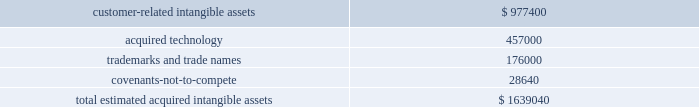Reach in the united states , adding a 1400-person direct sales force , over 300000 merchants and $ 130 billion in annual payments volume .
Goodwill of $ 3.2 billion arising from the merger , included in the north america segment , was attributable to expected growth opportunities , potential synergies from combining our existing businesses and an assembled workforce , and is not deductible for income tax purposes .
Due to the timing of our merger with heartland , we are still in the process of assigning goodwill to our reporting units .
During the year ended may 31 , 2016 , we incurred transaction costs in connection with the merger of $ 24.4 million , which are recorded in selling , general and administrative expenses in the consolidated statements of income .
The following reflects the preliminary estimated fair values of the identified intangible assets ( in thousands ) : .
The preliminary estimated fair value of customer-related intangible assets was determined using the income approach , which is based on projected cash flows discounted to their present value using discount rates that consider the timing and risk of the forecasted cash flows .
The discount rate used is the average estimated value of a market participant 2019s cost of capital and debt , derived using customary market metrics .
Other significant assumptions include terminal value margin rates , future capital expenditures and future working capital requirements .
Acquired technology was valued using the replacement cost method , which required us to estimate the cost to construct an asset of equivalent utility at prices available at the time of the valuation analysis , with adjustments in value for physical deterioration and functional and economic obsolescence .
Trademarks and trade names were valued using the relief-from-royalty approach .
This method assumes that trade marks and trade names have value to the extent that their owner is relieved of the obligation to pay royalties for the benefits received from them .
This method required us to estimate the future revenue for the related brands , the appropriate royalty rate and the weighted-average cost of capital .
The discount rate used is the average estimated value of a market participant 2019s cost of capital and debt , derived using customary market metrics .
The weighted-average estimated amortization period for the total estimated acquired intangible assets is approximately 11 years .
The customer-related intangible assets have an estimated amortization period range of 7-20 years .
The acquired technology has an estimated amortization period of 5 years .
The trademarks and trade names have an estimated amortization period of 7 years .
Covenants-not-to-compete have an estimated amortization period range of 1-4 years .
Heartland 2019s revenues and operating income represented approximately 4% ( 4 % ) and less than 0.5% ( 0.5 % ) of our total consolidated revenues and operating income , respectively , for the year ended may 31 , 2016 .
The following unaudited pro forma information shows the results of our operations for the years ended may 31 , 2016 and may 31 , 2015 as if our merger with heartland had occurred on june 1 , 2014 .
The unaudited pro forma information reflects the effects of applying our accounting policies and certain pro forma adjustments to the combined historical financial information of global payments and heartland .
The pro forma adjustments include incremental amortization and depreciation expense , incremental interest expense associated with new long-term debt , a reduction of revenues and operating expenses associated with fair value adjustments made in applying the acquisition-method of accounting and the elimination of nonrecurring transaction costs directly related to the merger .
Global payments inc .
| 2016 form 10-k annual report 2013 67 .
What is the yearly amortization expense related acquired technology? 
Computations: (457000 / 5)
Answer: 91400.0. Reach in the united states , adding a 1400-person direct sales force , over 300000 merchants and $ 130 billion in annual payments volume .
Goodwill of $ 3.2 billion arising from the merger , included in the north america segment , was attributable to expected growth opportunities , potential synergies from combining our existing businesses and an assembled workforce , and is not deductible for income tax purposes .
Due to the timing of our merger with heartland , we are still in the process of assigning goodwill to our reporting units .
During the year ended may 31 , 2016 , we incurred transaction costs in connection with the merger of $ 24.4 million , which are recorded in selling , general and administrative expenses in the consolidated statements of income .
The following reflects the preliminary estimated fair values of the identified intangible assets ( in thousands ) : .
The preliminary estimated fair value of customer-related intangible assets was determined using the income approach , which is based on projected cash flows discounted to their present value using discount rates that consider the timing and risk of the forecasted cash flows .
The discount rate used is the average estimated value of a market participant 2019s cost of capital and debt , derived using customary market metrics .
Other significant assumptions include terminal value margin rates , future capital expenditures and future working capital requirements .
Acquired technology was valued using the replacement cost method , which required us to estimate the cost to construct an asset of equivalent utility at prices available at the time of the valuation analysis , with adjustments in value for physical deterioration and functional and economic obsolescence .
Trademarks and trade names were valued using the relief-from-royalty approach .
This method assumes that trade marks and trade names have value to the extent that their owner is relieved of the obligation to pay royalties for the benefits received from them .
This method required us to estimate the future revenue for the related brands , the appropriate royalty rate and the weighted-average cost of capital .
The discount rate used is the average estimated value of a market participant 2019s cost of capital and debt , derived using customary market metrics .
The weighted-average estimated amortization period for the total estimated acquired intangible assets is approximately 11 years .
The customer-related intangible assets have an estimated amortization period range of 7-20 years .
The acquired technology has an estimated amortization period of 5 years .
The trademarks and trade names have an estimated amortization period of 7 years .
Covenants-not-to-compete have an estimated amortization period range of 1-4 years .
Heartland 2019s revenues and operating income represented approximately 4% ( 4 % ) and less than 0.5% ( 0.5 % ) of our total consolidated revenues and operating income , respectively , for the year ended may 31 , 2016 .
The following unaudited pro forma information shows the results of our operations for the years ended may 31 , 2016 and may 31 , 2015 as if our merger with heartland had occurred on june 1 , 2014 .
The unaudited pro forma information reflects the effects of applying our accounting policies and certain pro forma adjustments to the combined historical financial information of global payments and heartland .
The pro forma adjustments include incremental amortization and depreciation expense , incremental interest expense associated with new long-term debt , a reduction of revenues and operating expenses associated with fair value adjustments made in applying the acquisition-method of accounting and the elimination of nonrecurring transaction costs directly related to the merger .
Global payments inc .
| 2016 form 10-k annual report 2013 67 .
What is the yearly amortization expense related to trademarks and trade names? 
Computations: (176000 / 7)
Answer: 25142.85714. 